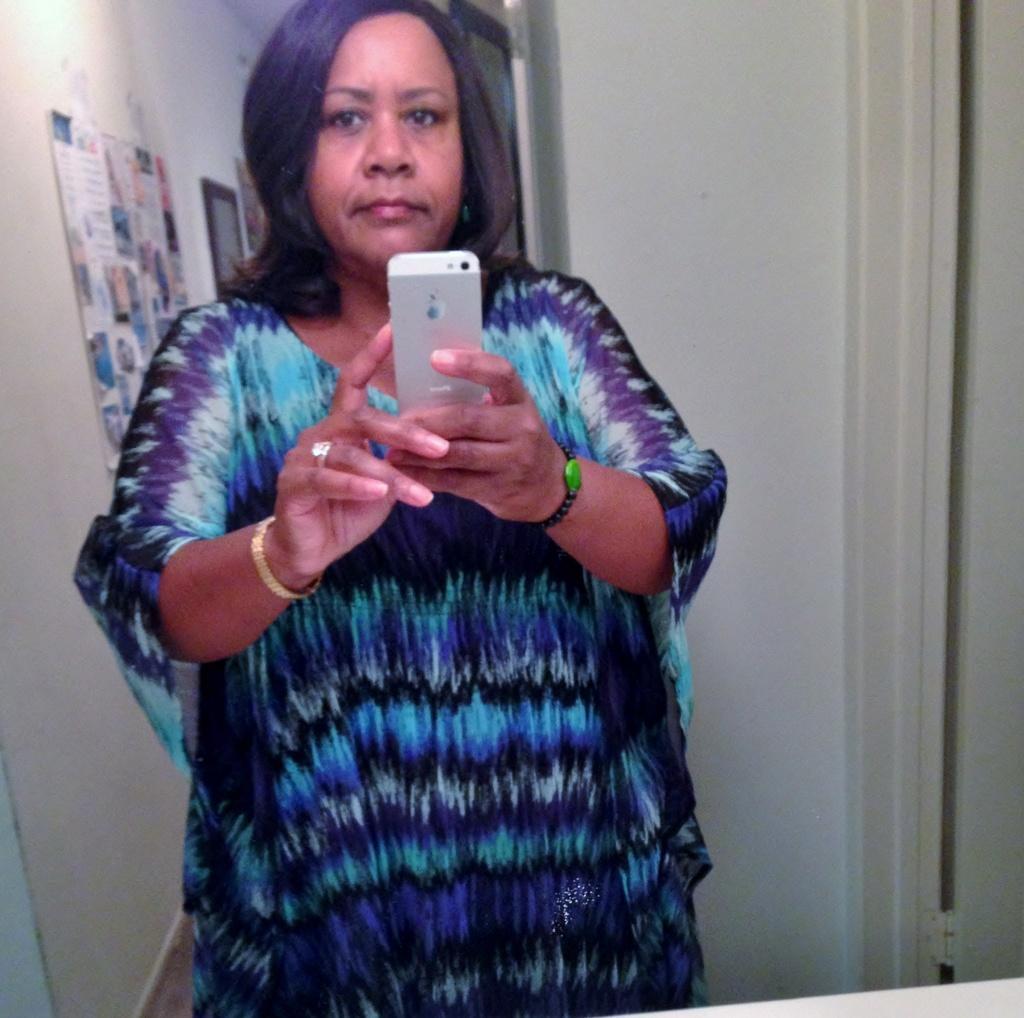Please provide a concise description of this image. In this image, I can see a mirror with the reflection of a woman standing and holding a mobile. On the right side of the image, It looks like a door. On the left side of the image, I can see a poster and a photo frame are attached to the wall. 